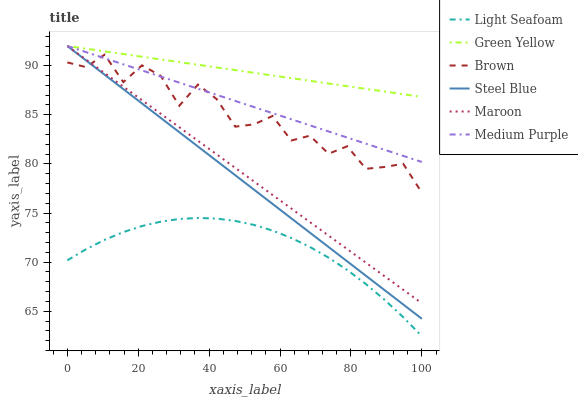Does Light Seafoam have the minimum area under the curve?
Answer yes or no. Yes. Does Green Yellow have the maximum area under the curve?
Answer yes or no. Yes. Does Steel Blue have the minimum area under the curve?
Answer yes or no. No. Does Steel Blue have the maximum area under the curve?
Answer yes or no. No. Is Medium Purple the smoothest?
Answer yes or no. Yes. Is Brown the roughest?
Answer yes or no. Yes. Is Light Seafoam the smoothest?
Answer yes or no. No. Is Light Seafoam the roughest?
Answer yes or no. No. Does Light Seafoam have the lowest value?
Answer yes or no. Yes. Does Steel Blue have the lowest value?
Answer yes or no. No. Does Green Yellow have the highest value?
Answer yes or no. Yes. Does Light Seafoam have the highest value?
Answer yes or no. No. Is Brown less than Green Yellow?
Answer yes or no. Yes. Is Steel Blue greater than Light Seafoam?
Answer yes or no. Yes. Does Brown intersect Maroon?
Answer yes or no. Yes. Is Brown less than Maroon?
Answer yes or no. No. Is Brown greater than Maroon?
Answer yes or no. No. Does Brown intersect Green Yellow?
Answer yes or no. No. 